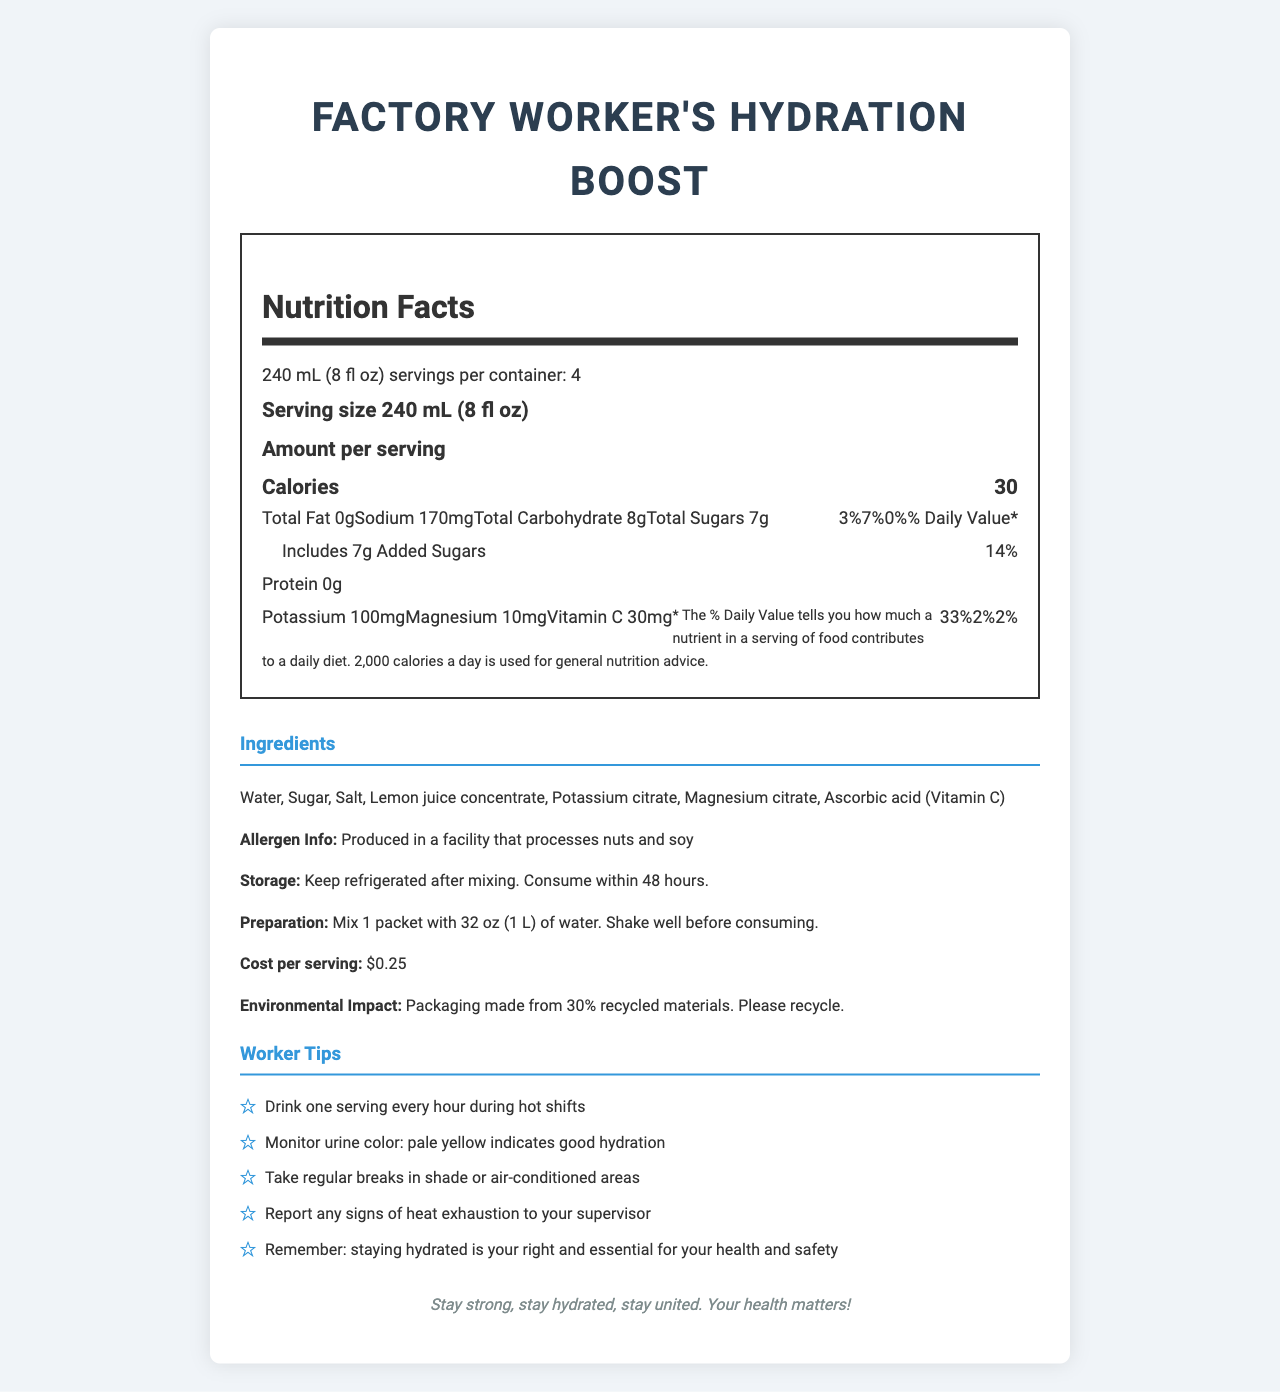what is the serving size? The serving size is explicitly stated in the document under the "Nutrition Facts" section.
Answer: 240 mL (8 fl oz) how many servings are in one container? According to the document, there are 4 servings per container.
Answer: 4 how many calories are in a single serving? The "Nutrition Facts" section lists the amount of calories per serving as 30.
Answer: 30 what is the amount of added sugars per serving? Under the "Total Sugars" section within "Total Carbohydrate", it specifies that there is 7g of added sugars per serving.
Answer: 7g what percentage of the daily value of Vitamin C does one serving provide? The document states that one serving provides 33% of the daily value of Vitamin C.
Answer: 33% what are the main ingredients of this electrolyte drink? The ingredients are listed explicitly in the "Ingredients" section of the document.
Answer: Water, Sugar, Salt, Lemon juice concentrate, Potassium citrate, Magnesium citrate, Ascorbic acid (Vitamin C) how should the drink be stored after mixing? The storage instructions in the document state it should be kept refrigerated and consumed within 48 hours.
Answer: Keep refrigerated after mixing. Consume within 48 hours. what should you do if you experience signs of heat exhaustion? One of the worker tips specifically advises to report any signs of heat exhaustion to your supervisor.
Answer: Report any signs of heat exhaustion to your supervisor which of the following nutrients is not found in this drink? A. Sodium B. Protein C. Magnesium D. Potassium The nutrition facts section states that the drink contains Sodium, Magnesium, and Potassium, but it shows "0g" for Protein.
Answer: B. Protein what is the cost per serving of the drink? A. $0.50 B. $0.75 C. $0.25 D. $1.00 The cost per serving is mentioned as $0.25 in the "Ingredients" section.
Answer: C. $0.25 is the drink produced in a facility that processes nuts and soy? The allergen information clearly states that the drink is produced in a facility that processes nuts and soy.
Answer: Yes summarize the main purpose of this document The document covers various aspects such as nutritional content, ingredients, preparation and storage instructions, cost per serving, environmental impact, and tips for workers to stay hydrated and safe.
Answer: The document provides comprehensive information about Factory Worker's Hydration Boost, a homemade electrolyte drink aimed at combating dehydration in hot work environments. It includes nutritional facts, ingredients, preparation instructions, storage guidelines, and worker tips to ensure safety and health. which vitamin is added to enhance the drink's benefits? The document lists Ascorbic acid (Vitamin C) as one of the ingredients and also highlights its daily value contribution.
Answer: Vitamin C what is the environmental impact mentioned in the document? The environmental impact section mentions that the packaging is made from 30% recycled materials and encourages recycling.
Answer: Packaging made from 30% recycled materials. Please recycle. how many hours can the beverage be safely consumed once prepared? The storage instructions indicate that the drink should be consumed within 48 hours after mixing.
Answer: 48 hours does the document mention the exact factory where the drink is produced? The document does not provide the specific details about the factory where the drink is produced.
Answer: Not enough information 